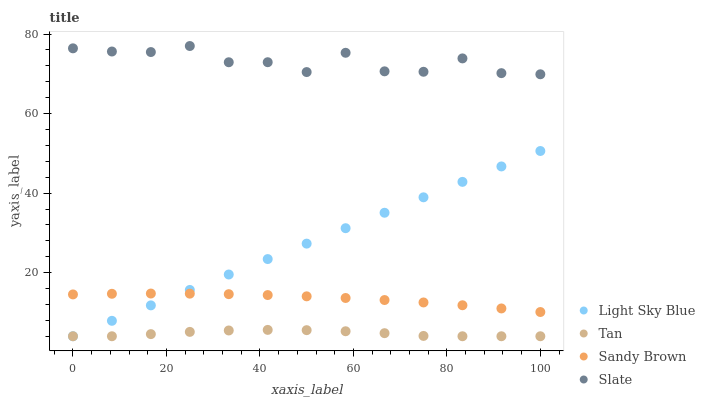Does Tan have the minimum area under the curve?
Answer yes or no. Yes. Does Slate have the maximum area under the curve?
Answer yes or no. Yes. Does Light Sky Blue have the minimum area under the curve?
Answer yes or no. No. Does Light Sky Blue have the maximum area under the curve?
Answer yes or no. No. Is Light Sky Blue the smoothest?
Answer yes or no. Yes. Is Slate the roughest?
Answer yes or no. Yes. Is Sandy Brown the smoothest?
Answer yes or no. No. Is Sandy Brown the roughest?
Answer yes or no. No. Does Tan have the lowest value?
Answer yes or no. Yes. Does Sandy Brown have the lowest value?
Answer yes or no. No. Does Slate have the highest value?
Answer yes or no. Yes. Does Light Sky Blue have the highest value?
Answer yes or no. No. Is Tan less than Sandy Brown?
Answer yes or no. Yes. Is Slate greater than Tan?
Answer yes or no. Yes. Does Light Sky Blue intersect Sandy Brown?
Answer yes or no. Yes. Is Light Sky Blue less than Sandy Brown?
Answer yes or no. No. Is Light Sky Blue greater than Sandy Brown?
Answer yes or no. No. Does Tan intersect Sandy Brown?
Answer yes or no. No. 